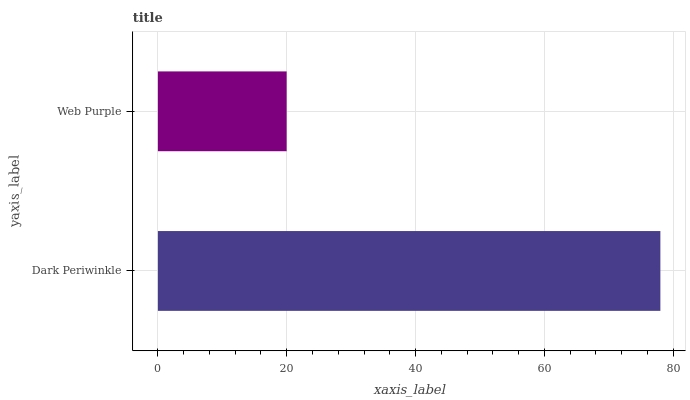Is Web Purple the minimum?
Answer yes or no. Yes. Is Dark Periwinkle the maximum?
Answer yes or no. Yes. Is Web Purple the maximum?
Answer yes or no. No. Is Dark Periwinkle greater than Web Purple?
Answer yes or no. Yes. Is Web Purple less than Dark Periwinkle?
Answer yes or no. Yes. Is Web Purple greater than Dark Periwinkle?
Answer yes or no. No. Is Dark Periwinkle less than Web Purple?
Answer yes or no. No. Is Dark Periwinkle the high median?
Answer yes or no. Yes. Is Web Purple the low median?
Answer yes or no. Yes. Is Web Purple the high median?
Answer yes or no. No. Is Dark Periwinkle the low median?
Answer yes or no. No. 